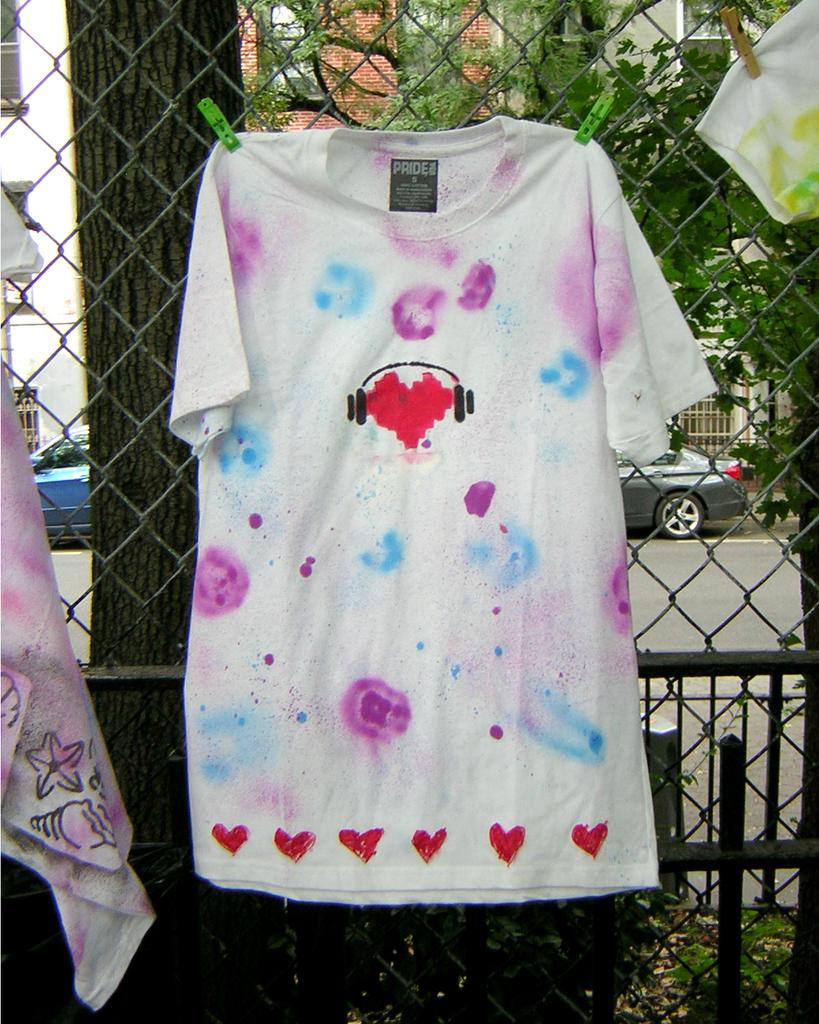What is being hung on the net fence in the image? Clothes are being hung on a net fence with the help of clips. What type of vegetation can be seen in the image? There are trees visible in the image. What is present on the road in the image? There are vehicles on the road in the image. What type of structures can be seen in the image? There are buildings visible in the image. What type of liquid can be seen falling from the sky in the image? There is no liquid falling from the sky in the image; it is not raining or snowing. 